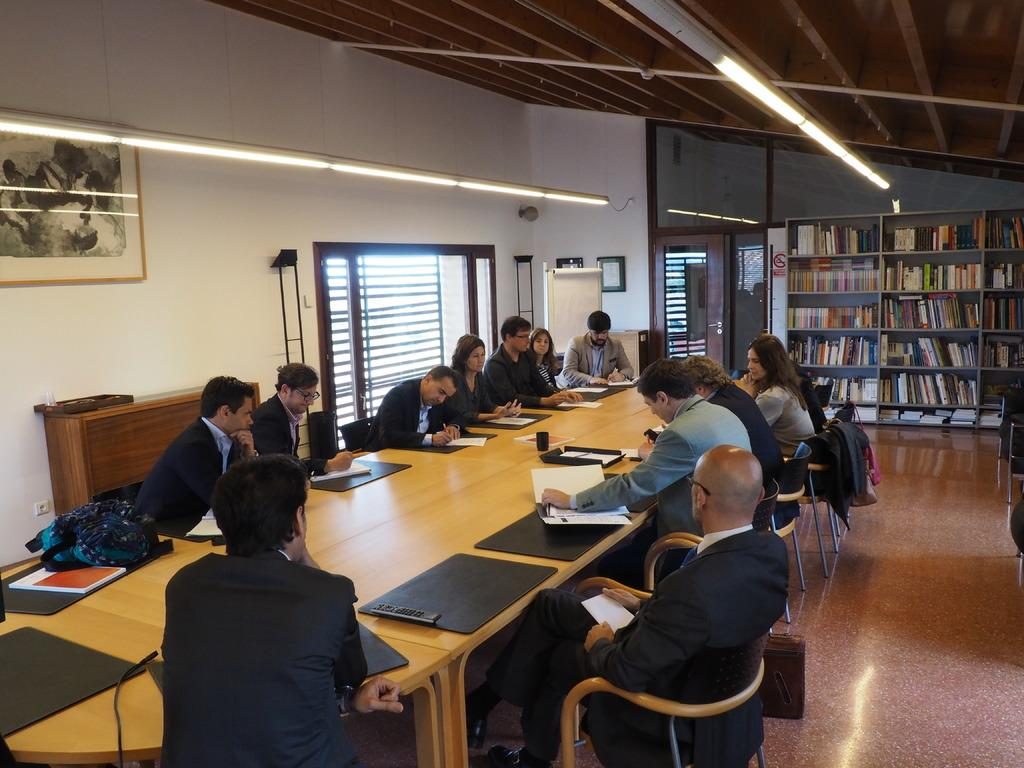What are the people in the image doing? There is a group of people sitting around a table. What is in the middle of the table? There is a light in the middle of the table. Where are the books located in the image? The books are on a shelf. What color does the light turn when someone watches it closely? There is no indication in the image that the light changes color or that anyone is watching it closely. 